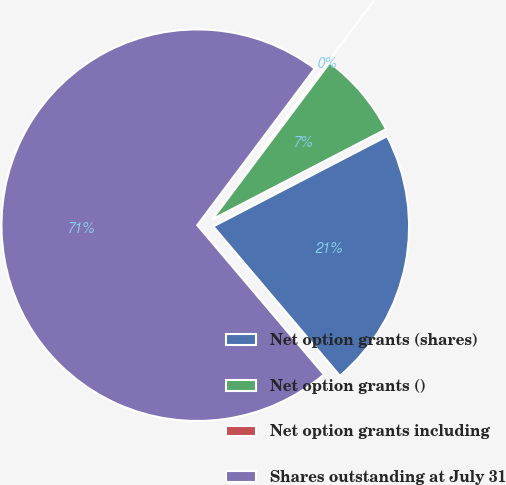Convert chart to OTSL. <chart><loc_0><loc_0><loc_500><loc_500><pie_chart><fcel>Net option grants (shares)<fcel>Net option grants ()<fcel>Net option grants including<fcel>Shares outstanding at July 31<nl><fcel>21.43%<fcel>7.14%<fcel>0.0%<fcel>71.43%<nl></chart> 